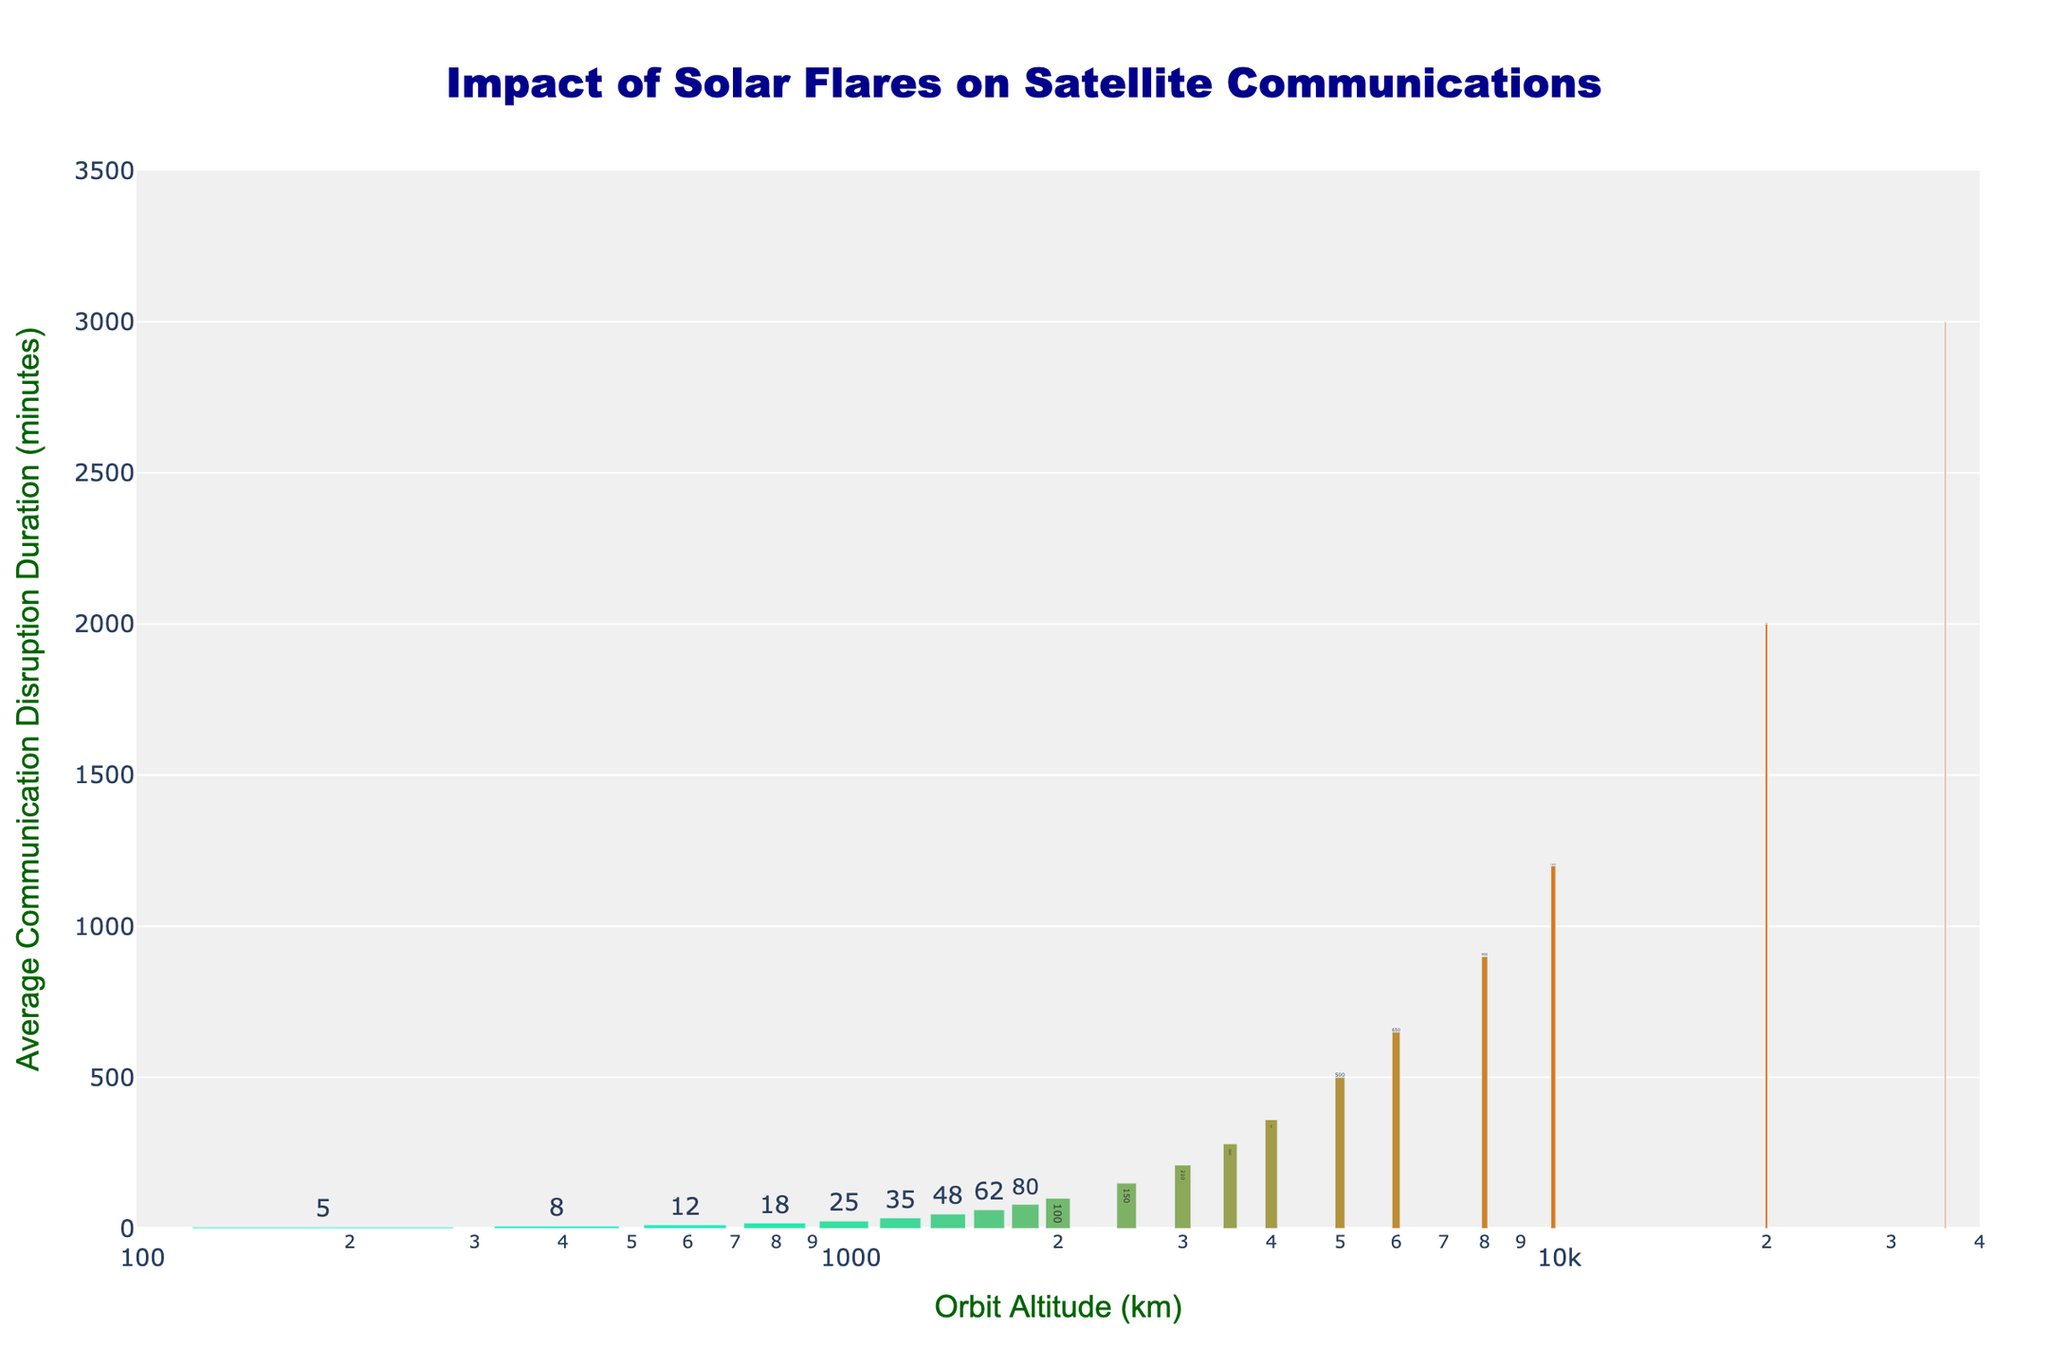What's the approximate average disruption duration for satellites in orbit altitudes between 200 km and 2000 km? To find the average disruption duration for orbit altitudes between 200 km and 2000 km, we identify data points: 5, 8, 12, 18, 25, 35, 48, 62, 80, and 100. Summing these values gives 393. There are 10 data points, so the average is 393/10 = 39.3
Answer: 39.3 minutes Which orbit altitude has the shortest communication disruption duration? The shortest disruption duration among the different orbit altitudes is 5 minutes, which corresponds to an altitude of 200 km.
Answer: 200 km How does the communication disruption duration at 10,000 km compare to that at 20,000 km? At 10,000 km, the duration is 1,200 minutes, and at 20,000 km, it is 2,000 minutes. Comparing these values shows that the disruption duration at 20,000 km is longer.
Answer: 20,000 km has a longer duration Is there a growing trend in disruption duration with increasing orbit altitude? Yes, as the orbit altitude increases from 200 km to 35,786 km, the disruption duration consistently increases, indicating a positive growth trend.
Answer: Yes What is the difference in communication disruption duration between 8,000 km and 3,500 km? The disruption duration at 8,000 km is 900 minutes, and at 3,500 km, it is 280 minutes. Subtracting these values gives 900 - 280 = 620 minutes.
Answer: 620 minutes What is the longest communication disruption duration noted in the figure? The longest disruption duration is 3,000 minutes, which corresponds to an orbit altitude of 35,786 km.
Answer: 3,000 minutes Which orbit altitude range shows a steep increase in disruption duration? Between 6,000 km (650 minutes) and 10,000 km (1,200 minutes), there is a notable steep increase in disruption duration, jumping by 550 minutes.
Answer: 6,000 km to 10,000 km What is the overall trend of the bar colors as the orbit altitude increases? The bars transition from a lighter color at lower altitudes to a darker color at higher altitudes, indicating a gradient effect reflecting increasing disruption durations.
Answer: Darker colors at higher altitudes By how much does the disruption duration increase from 2,500 km to 4,000 km? At 2,500 km, the disruption duration is 150 minutes, and at 4,000 km, it is 360 minutes. The increase is 360 - 150 = 210 minutes.
Answer: 210 minutes What orbit altitude corresponds to a disruption duration close to 48 minutes? A disruption duration of 48 minutes corresponds to an orbit altitude of 1,400 km.
Answer: 1,400 km 